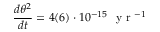Convert formula to latex. <formula><loc_0><loc_0><loc_500><loc_500>\frac { d \theta ^ { 2 } } { d t } = 4 ( 6 ) \cdot 1 0 ^ { - 1 5 } \ y r ^ { - 1 }</formula> 